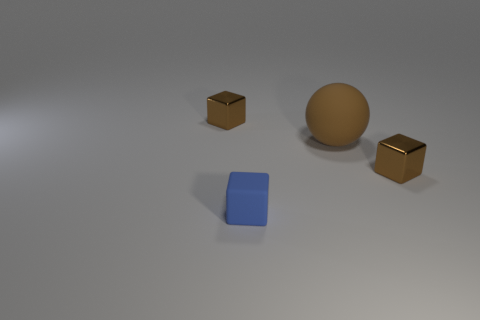Add 1 tiny objects. How many objects exist? 5 Subtract all spheres. How many objects are left? 3 Subtract 0 red cubes. How many objects are left? 4 Subtract all small blue objects. Subtract all small blocks. How many objects are left? 0 Add 3 blue rubber objects. How many blue rubber objects are left? 4 Add 1 small blue objects. How many small blue objects exist? 2 